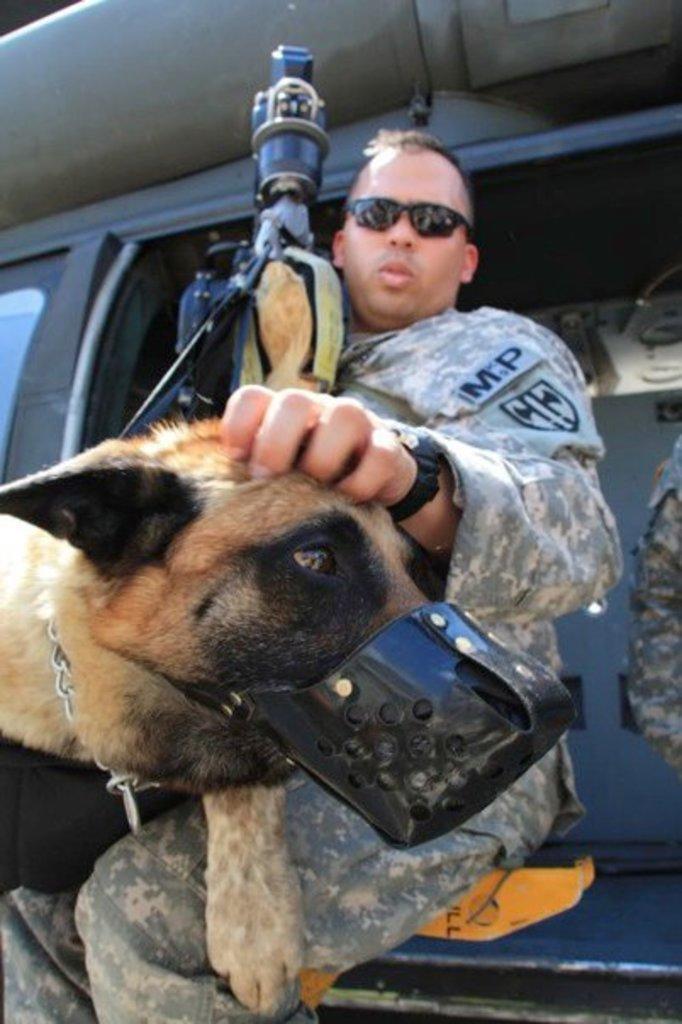Can you describe this image briefly? In this image I can see a dog which is brown and black in color and I can see a person wearing uniform is holding the dog and I can see he is sitting in a vehicle which is black in color. 